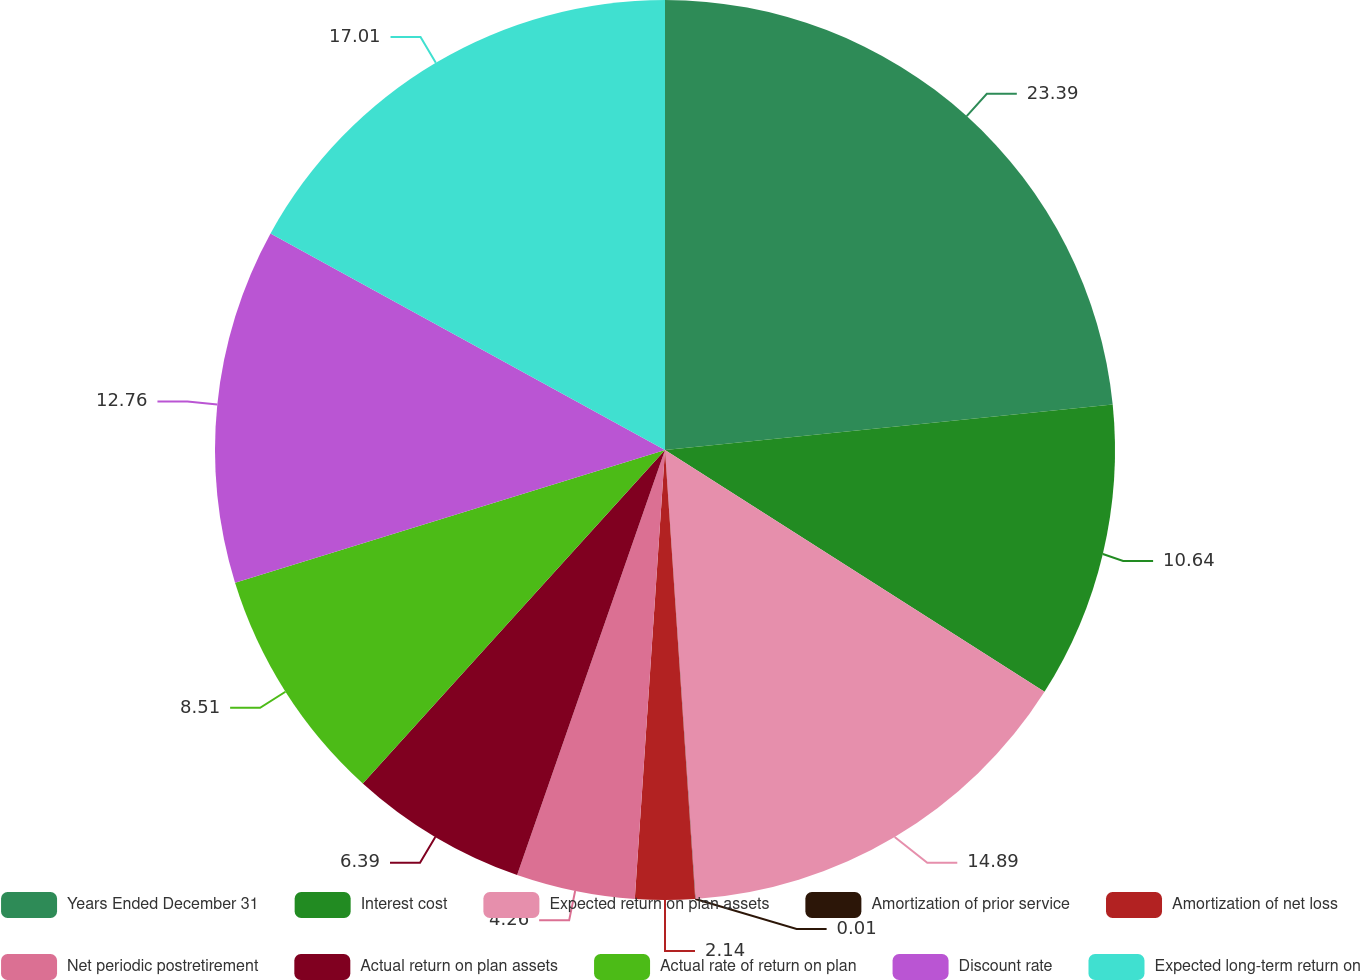<chart> <loc_0><loc_0><loc_500><loc_500><pie_chart><fcel>Years Ended December 31<fcel>Interest cost<fcel>Expected return on plan assets<fcel>Amortization of prior service<fcel>Amortization of net loss<fcel>Net periodic postretirement<fcel>Actual return on plan assets<fcel>Actual rate of return on plan<fcel>Discount rate<fcel>Expected long-term return on<nl><fcel>23.39%<fcel>10.64%<fcel>14.89%<fcel>0.01%<fcel>2.14%<fcel>4.26%<fcel>6.39%<fcel>8.51%<fcel>12.76%<fcel>17.01%<nl></chart> 